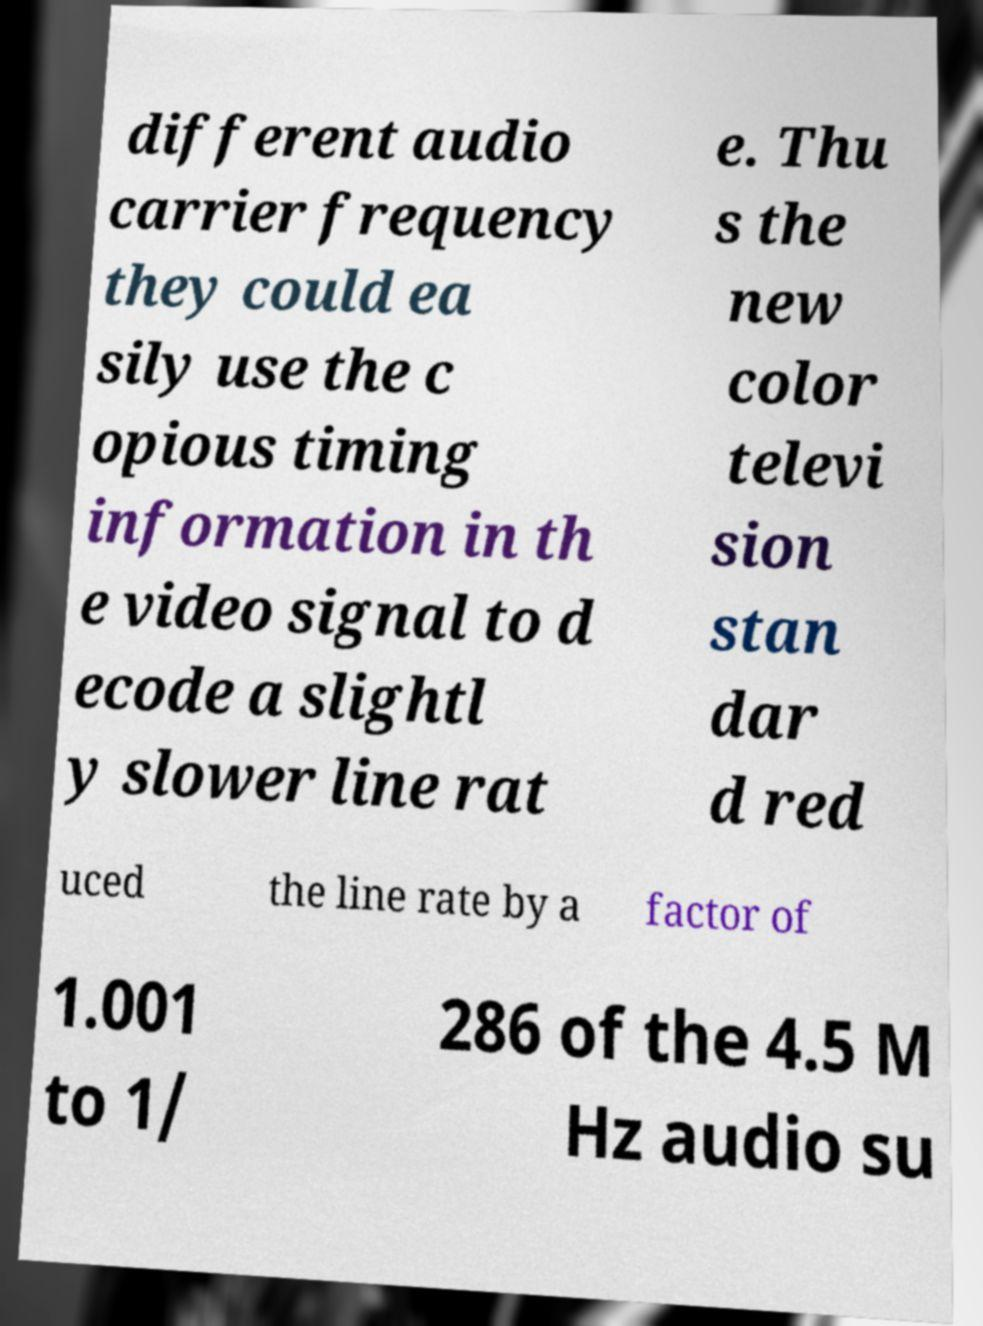There's text embedded in this image that I need extracted. Can you transcribe it verbatim? different audio carrier frequency they could ea sily use the c opious timing information in th e video signal to d ecode a slightl y slower line rat e. Thu s the new color televi sion stan dar d red uced the line rate by a factor of 1.001 to 1/ 286 of the 4.5 M Hz audio su 